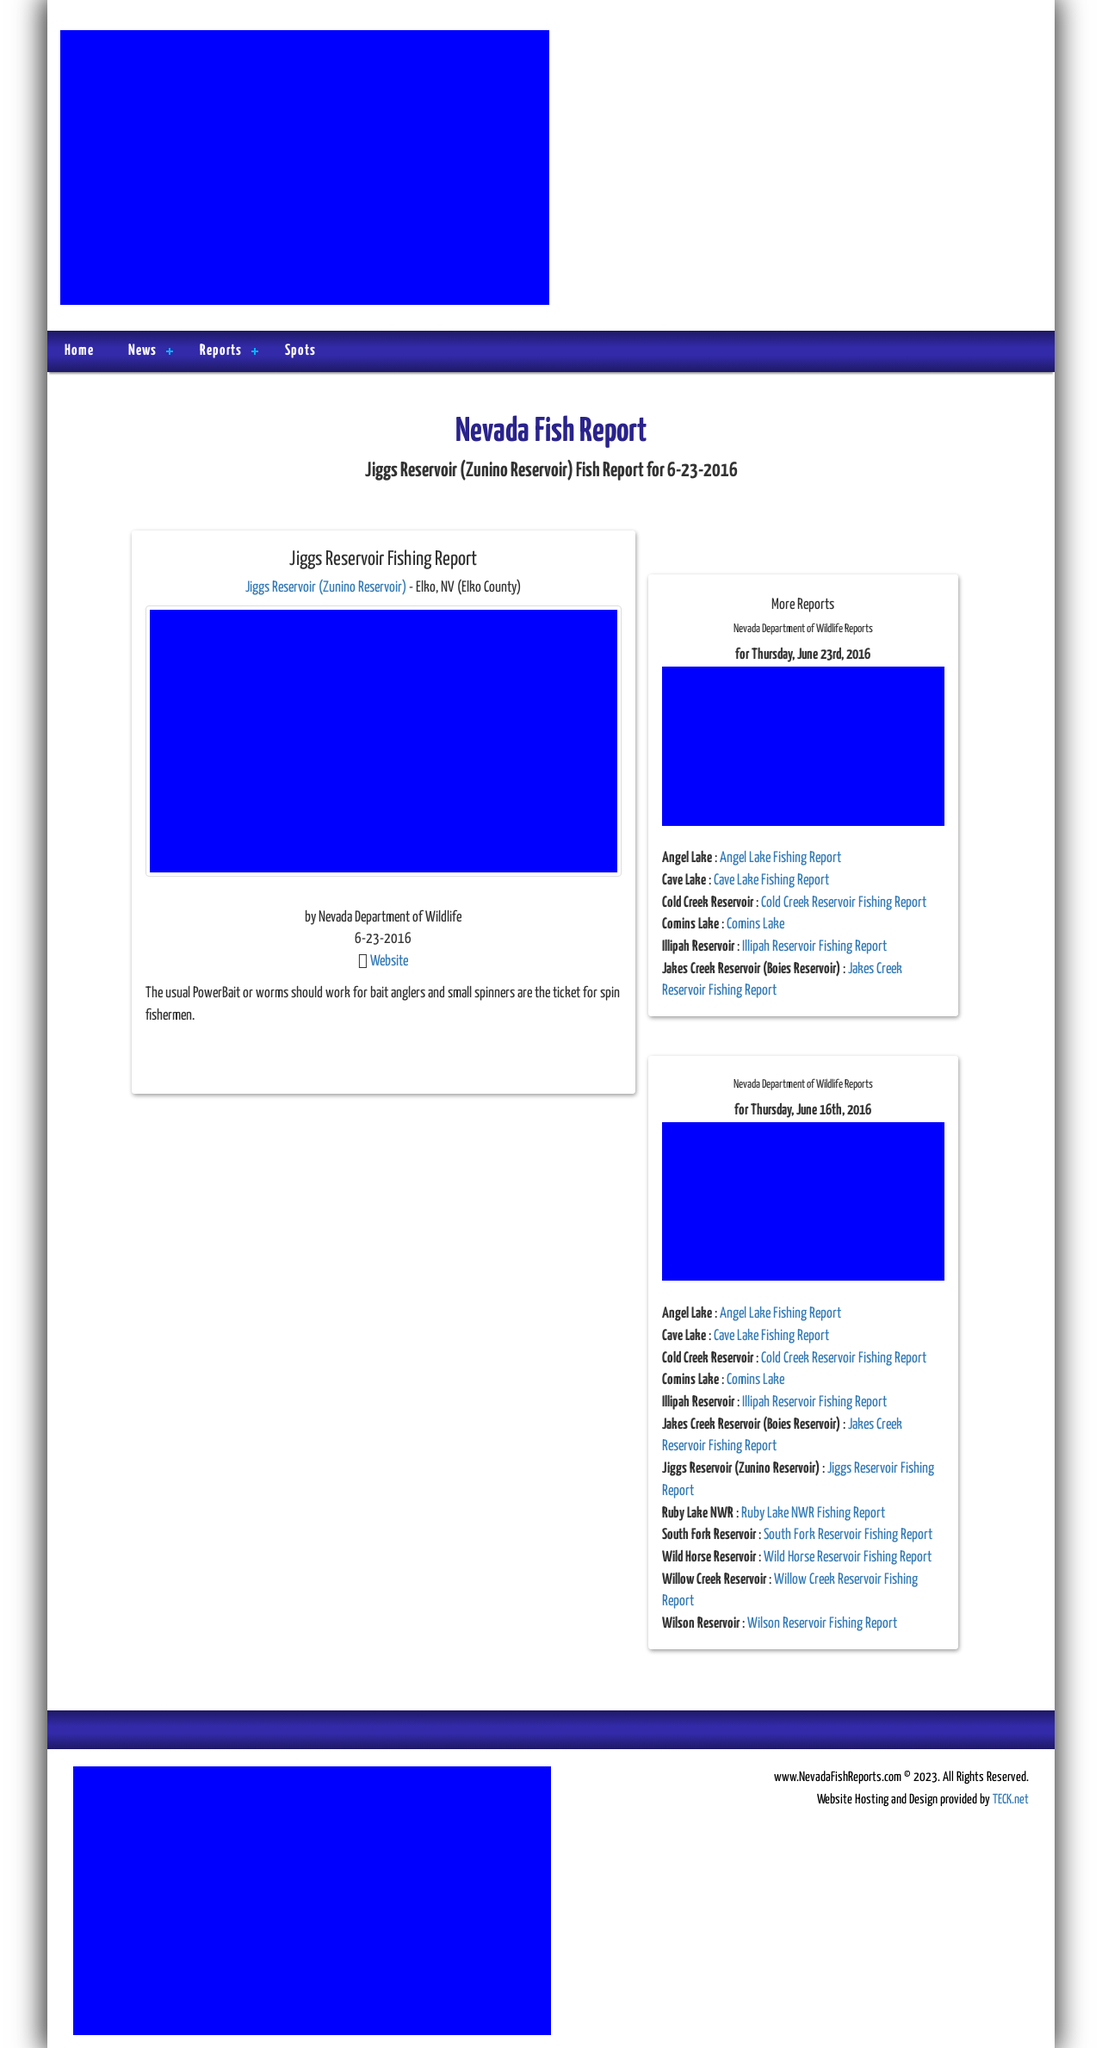Could you detail the process for assembling this website using HTML? Certainly! Assembling a website using HTML involves several key steps. Firstly, you would start by defining the document type and the HTML structure. The provided sample HTML outlines the basic setup with a head and body section. In the head, you'd typically include meta tags, which are essential for SEO and setting character set, stylesheets for controlling the appearance, and scripts for added functionality. The body of the HTML is where the content and other interactive elements are placed. For a robust site, like the one in this image of a fishing report website, you would also need to integrate CSS for styling, JavaScript for dynamic elements, and potentially backend programming for handling the retrieval and storage of data such as fishing reports and updates. 